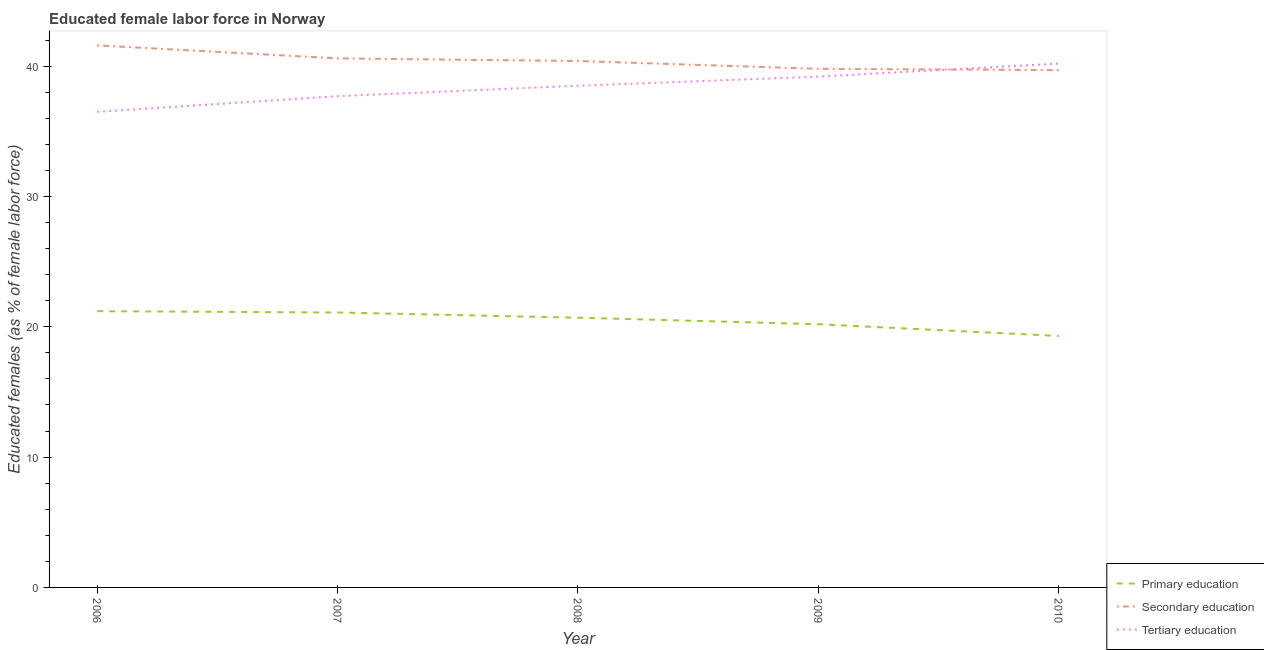How many different coloured lines are there?
Offer a very short reply. 3. Is the number of lines equal to the number of legend labels?
Provide a succinct answer. Yes. What is the percentage of female labor force who received primary education in 2007?
Offer a terse response. 21.1. Across all years, what is the maximum percentage of female labor force who received secondary education?
Give a very brief answer. 41.6. Across all years, what is the minimum percentage of female labor force who received secondary education?
Offer a very short reply. 39.7. In which year was the percentage of female labor force who received secondary education maximum?
Provide a succinct answer. 2006. In which year was the percentage of female labor force who received secondary education minimum?
Provide a succinct answer. 2010. What is the total percentage of female labor force who received tertiary education in the graph?
Your answer should be compact. 192.1. What is the difference between the percentage of female labor force who received primary education in 2007 and that in 2008?
Your response must be concise. 0.4. What is the difference between the percentage of female labor force who received secondary education in 2006 and the percentage of female labor force who received tertiary education in 2009?
Your answer should be very brief. 2.4. What is the average percentage of female labor force who received secondary education per year?
Provide a succinct answer. 40.42. In the year 2007, what is the difference between the percentage of female labor force who received primary education and percentage of female labor force who received secondary education?
Keep it short and to the point. -19.5. What is the ratio of the percentage of female labor force who received tertiary education in 2007 to that in 2008?
Make the answer very short. 0.98. Is the percentage of female labor force who received primary education in 2008 less than that in 2009?
Provide a short and direct response. No. Is the difference between the percentage of female labor force who received secondary education in 2006 and 2008 greater than the difference between the percentage of female labor force who received primary education in 2006 and 2008?
Your response must be concise. Yes. What is the difference between the highest and the second highest percentage of female labor force who received primary education?
Give a very brief answer. 0.1. What is the difference between the highest and the lowest percentage of female labor force who received primary education?
Offer a very short reply. 1.9. In how many years, is the percentage of female labor force who received primary education greater than the average percentage of female labor force who received primary education taken over all years?
Your response must be concise. 3. Is the sum of the percentage of female labor force who received secondary education in 2006 and 2007 greater than the maximum percentage of female labor force who received primary education across all years?
Your response must be concise. Yes. Is it the case that in every year, the sum of the percentage of female labor force who received primary education and percentage of female labor force who received secondary education is greater than the percentage of female labor force who received tertiary education?
Provide a succinct answer. Yes. Is the percentage of female labor force who received secondary education strictly less than the percentage of female labor force who received tertiary education over the years?
Give a very brief answer. No. How many lines are there?
Give a very brief answer. 3. How many years are there in the graph?
Give a very brief answer. 5. Are the values on the major ticks of Y-axis written in scientific E-notation?
Ensure brevity in your answer.  No. Where does the legend appear in the graph?
Your response must be concise. Bottom right. How many legend labels are there?
Provide a short and direct response. 3. What is the title of the graph?
Your answer should be very brief. Educated female labor force in Norway. Does "Infant(male)" appear as one of the legend labels in the graph?
Provide a short and direct response. No. What is the label or title of the X-axis?
Provide a succinct answer. Year. What is the label or title of the Y-axis?
Ensure brevity in your answer.  Educated females (as % of female labor force). What is the Educated females (as % of female labor force) in Primary education in 2006?
Keep it short and to the point. 21.2. What is the Educated females (as % of female labor force) of Secondary education in 2006?
Offer a terse response. 41.6. What is the Educated females (as % of female labor force) in Tertiary education in 2006?
Your answer should be very brief. 36.5. What is the Educated females (as % of female labor force) of Primary education in 2007?
Make the answer very short. 21.1. What is the Educated females (as % of female labor force) in Secondary education in 2007?
Your response must be concise. 40.6. What is the Educated females (as % of female labor force) of Tertiary education in 2007?
Ensure brevity in your answer.  37.7. What is the Educated females (as % of female labor force) of Primary education in 2008?
Provide a succinct answer. 20.7. What is the Educated females (as % of female labor force) of Secondary education in 2008?
Keep it short and to the point. 40.4. What is the Educated females (as % of female labor force) in Tertiary education in 2008?
Offer a terse response. 38.5. What is the Educated females (as % of female labor force) in Primary education in 2009?
Give a very brief answer. 20.2. What is the Educated females (as % of female labor force) in Secondary education in 2009?
Offer a very short reply. 39.8. What is the Educated females (as % of female labor force) in Tertiary education in 2009?
Offer a very short reply. 39.2. What is the Educated females (as % of female labor force) in Primary education in 2010?
Provide a succinct answer. 19.3. What is the Educated females (as % of female labor force) in Secondary education in 2010?
Your response must be concise. 39.7. What is the Educated females (as % of female labor force) of Tertiary education in 2010?
Your response must be concise. 40.2. Across all years, what is the maximum Educated females (as % of female labor force) of Primary education?
Offer a very short reply. 21.2. Across all years, what is the maximum Educated females (as % of female labor force) of Secondary education?
Offer a very short reply. 41.6. Across all years, what is the maximum Educated females (as % of female labor force) of Tertiary education?
Your response must be concise. 40.2. Across all years, what is the minimum Educated females (as % of female labor force) in Primary education?
Make the answer very short. 19.3. Across all years, what is the minimum Educated females (as % of female labor force) in Secondary education?
Make the answer very short. 39.7. Across all years, what is the minimum Educated females (as % of female labor force) of Tertiary education?
Offer a very short reply. 36.5. What is the total Educated females (as % of female labor force) in Primary education in the graph?
Make the answer very short. 102.5. What is the total Educated females (as % of female labor force) in Secondary education in the graph?
Provide a succinct answer. 202.1. What is the total Educated females (as % of female labor force) of Tertiary education in the graph?
Offer a very short reply. 192.1. What is the difference between the Educated females (as % of female labor force) of Primary education in 2006 and that in 2007?
Provide a short and direct response. 0.1. What is the difference between the Educated females (as % of female labor force) of Tertiary education in 2006 and that in 2007?
Offer a terse response. -1.2. What is the difference between the Educated females (as % of female labor force) in Secondary education in 2006 and that in 2008?
Your answer should be very brief. 1.2. What is the difference between the Educated females (as % of female labor force) of Tertiary education in 2006 and that in 2008?
Your answer should be compact. -2. What is the difference between the Educated females (as % of female labor force) in Primary education in 2006 and that in 2009?
Make the answer very short. 1. What is the difference between the Educated females (as % of female labor force) of Primary education in 2006 and that in 2010?
Your answer should be compact. 1.9. What is the difference between the Educated females (as % of female labor force) in Tertiary education in 2006 and that in 2010?
Provide a short and direct response. -3.7. What is the difference between the Educated females (as % of female labor force) of Primary education in 2007 and that in 2008?
Your response must be concise. 0.4. What is the difference between the Educated females (as % of female labor force) of Tertiary education in 2007 and that in 2008?
Keep it short and to the point. -0.8. What is the difference between the Educated females (as % of female labor force) in Tertiary education in 2007 and that in 2010?
Your response must be concise. -2.5. What is the difference between the Educated females (as % of female labor force) in Tertiary education in 2008 and that in 2009?
Ensure brevity in your answer.  -0.7. What is the difference between the Educated females (as % of female labor force) of Secondary education in 2008 and that in 2010?
Offer a terse response. 0.7. What is the difference between the Educated females (as % of female labor force) in Tertiary education in 2009 and that in 2010?
Your answer should be very brief. -1. What is the difference between the Educated females (as % of female labor force) of Primary education in 2006 and the Educated females (as % of female labor force) of Secondary education in 2007?
Make the answer very short. -19.4. What is the difference between the Educated females (as % of female labor force) in Primary education in 2006 and the Educated females (as % of female labor force) in Tertiary education in 2007?
Offer a very short reply. -16.5. What is the difference between the Educated females (as % of female labor force) in Primary education in 2006 and the Educated females (as % of female labor force) in Secondary education in 2008?
Ensure brevity in your answer.  -19.2. What is the difference between the Educated females (as % of female labor force) of Primary education in 2006 and the Educated females (as % of female labor force) of Tertiary education in 2008?
Offer a very short reply. -17.3. What is the difference between the Educated females (as % of female labor force) of Secondary education in 2006 and the Educated females (as % of female labor force) of Tertiary education in 2008?
Provide a succinct answer. 3.1. What is the difference between the Educated females (as % of female labor force) in Primary education in 2006 and the Educated females (as % of female labor force) in Secondary education in 2009?
Offer a terse response. -18.6. What is the difference between the Educated females (as % of female labor force) of Primary education in 2006 and the Educated females (as % of female labor force) of Tertiary education in 2009?
Keep it short and to the point. -18. What is the difference between the Educated females (as % of female labor force) in Secondary education in 2006 and the Educated females (as % of female labor force) in Tertiary education in 2009?
Offer a terse response. 2.4. What is the difference between the Educated females (as % of female labor force) of Primary education in 2006 and the Educated females (as % of female labor force) of Secondary education in 2010?
Your answer should be compact. -18.5. What is the difference between the Educated females (as % of female labor force) in Secondary education in 2006 and the Educated females (as % of female labor force) in Tertiary education in 2010?
Your answer should be very brief. 1.4. What is the difference between the Educated females (as % of female labor force) of Primary education in 2007 and the Educated females (as % of female labor force) of Secondary education in 2008?
Provide a short and direct response. -19.3. What is the difference between the Educated females (as % of female labor force) of Primary education in 2007 and the Educated females (as % of female labor force) of Tertiary education in 2008?
Keep it short and to the point. -17.4. What is the difference between the Educated females (as % of female labor force) of Primary education in 2007 and the Educated females (as % of female labor force) of Secondary education in 2009?
Keep it short and to the point. -18.7. What is the difference between the Educated females (as % of female labor force) of Primary education in 2007 and the Educated females (as % of female labor force) of Tertiary education in 2009?
Your response must be concise. -18.1. What is the difference between the Educated females (as % of female labor force) in Primary education in 2007 and the Educated females (as % of female labor force) in Secondary education in 2010?
Your answer should be compact. -18.6. What is the difference between the Educated females (as % of female labor force) of Primary education in 2007 and the Educated females (as % of female labor force) of Tertiary education in 2010?
Offer a very short reply. -19.1. What is the difference between the Educated females (as % of female labor force) of Secondary education in 2007 and the Educated females (as % of female labor force) of Tertiary education in 2010?
Your answer should be very brief. 0.4. What is the difference between the Educated females (as % of female labor force) in Primary education in 2008 and the Educated females (as % of female labor force) in Secondary education in 2009?
Offer a terse response. -19.1. What is the difference between the Educated females (as % of female labor force) of Primary education in 2008 and the Educated females (as % of female labor force) of Tertiary education in 2009?
Offer a very short reply. -18.5. What is the difference between the Educated females (as % of female labor force) in Secondary education in 2008 and the Educated females (as % of female labor force) in Tertiary education in 2009?
Keep it short and to the point. 1.2. What is the difference between the Educated females (as % of female labor force) of Primary education in 2008 and the Educated females (as % of female labor force) of Tertiary education in 2010?
Keep it short and to the point. -19.5. What is the difference between the Educated females (as % of female labor force) of Secondary education in 2008 and the Educated females (as % of female labor force) of Tertiary education in 2010?
Make the answer very short. 0.2. What is the difference between the Educated females (as % of female labor force) of Primary education in 2009 and the Educated females (as % of female labor force) of Secondary education in 2010?
Provide a short and direct response. -19.5. What is the average Educated females (as % of female labor force) of Secondary education per year?
Ensure brevity in your answer.  40.42. What is the average Educated females (as % of female labor force) of Tertiary education per year?
Keep it short and to the point. 38.42. In the year 2006, what is the difference between the Educated females (as % of female labor force) of Primary education and Educated females (as % of female labor force) of Secondary education?
Provide a short and direct response. -20.4. In the year 2006, what is the difference between the Educated females (as % of female labor force) in Primary education and Educated females (as % of female labor force) in Tertiary education?
Provide a succinct answer. -15.3. In the year 2006, what is the difference between the Educated females (as % of female labor force) in Secondary education and Educated females (as % of female labor force) in Tertiary education?
Ensure brevity in your answer.  5.1. In the year 2007, what is the difference between the Educated females (as % of female labor force) of Primary education and Educated females (as % of female labor force) of Secondary education?
Your answer should be very brief. -19.5. In the year 2007, what is the difference between the Educated females (as % of female labor force) in Primary education and Educated females (as % of female labor force) in Tertiary education?
Ensure brevity in your answer.  -16.6. In the year 2008, what is the difference between the Educated females (as % of female labor force) of Primary education and Educated females (as % of female labor force) of Secondary education?
Your answer should be very brief. -19.7. In the year 2008, what is the difference between the Educated females (as % of female labor force) of Primary education and Educated females (as % of female labor force) of Tertiary education?
Ensure brevity in your answer.  -17.8. In the year 2008, what is the difference between the Educated females (as % of female labor force) of Secondary education and Educated females (as % of female labor force) of Tertiary education?
Give a very brief answer. 1.9. In the year 2009, what is the difference between the Educated females (as % of female labor force) of Primary education and Educated females (as % of female labor force) of Secondary education?
Offer a very short reply. -19.6. In the year 2009, what is the difference between the Educated females (as % of female labor force) of Primary education and Educated females (as % of female labor force) of Tertiary education?
Your response must be concise. -19. In the year 2009, what is the difference between the Educated females (as % of female labor force) in Secondary education and Educated females (as % of female labor force) in Tertiary education?
Give a very brief answer. 0.6. In the year 2010, what is the difference between the Educated females (as % of female labor force) in Primary education and Educated females (as % of female labor force) in Secondary education?
Make the answer very short. -20.4. In the year 2010, what is the difference between the Educated females (as % of female labor force) in Primary education and Educated females (as % of female labor force) in Tertiary education?
Your answer should be very brief. -20.9. In the year 2010, what is the difference between the Educated females (as % of female labor force) in Secondary education and Educated females (as % of female labor force) in Tertiary education?
Give a very brief answer. -0.5. What is the ratio of the Educated females (as % of female labor force) in Secondary education in 2006 to that in 2007?
Provide a succinct answer. 1.02. What is the ratio of the Educated females (as % of female labor force) in Tertiary education in 2006 to that in 2007?
Keep it short and to the point. 0.97. What is the ratio of the Educated females (as % of female labor force) of Primary education in 2006 to that in 2008?
Your answer should be very brief. 1.02. What is the ratio of the Educated females (as % of female labor force) of Secondary education in 2006 to that in 2008?
Offer a terse response. 1.03. What is the ratio of the Educated females (as % of female labor force) of Tertiary education in 2006 to that in 2008?
Offer a terse response. 0.95. What is the ratio of the Educated females (as % of female labor force) of Primary education in 2006 to that in 2009?
Offer a very short reply. 1.05. What is the ratio of the Educated females (as % of female labor force) in Secondary education in 2006 to that in 2009?
Make the answer very short. 1.05. What is the ratio of the Educated females (as % of female labor force) in Tertiary education in 2006 to that in 2009?
Ensure brevity in your answer.  0.93. What is the ratio of the Educated females (as % of female labor force) of Primary education in 2006 to that in 2010?
Offer a very short reply. 1.1. What is the ratio of the Educated females (as % of female labor force) of Secondary education in 2006 to that in 2010?
Make the answer very short. 1.05. What is the ratio of the Educated females (as % of female labor force) of Tertiary education in 2006 to that in 2010?
Give a very brief answer. 0.91. What is the ratio of the Educated females (as % of female labor force) in Primary education in 2007 to that in 2008?
Provide a succinct answer. 1.02. What is the ratio of the Educated females (as % of female labor force) in Tertiary education in 2007 to that in 2008?
Ensure brevity in your answer.  0.98. What is the ratio of the Educated females (as % of female labor force) in Primary education in 2007 to that in 2009?
Your answer should be very brief. 1.04. What is the ratio of the Educated females (as % of female labor force) in Secondary education in 2007 to that in 2009?
Provide a succinct answer. 1.02. What is the ratio of the Educated females (as % of female labor force) in Tertiary education in 2007 to that in 2009?
Offer a very short reply. 0.96. What is the ratio of the Educated females (as % of female labor force) of Primary education in 2007 to that in 2010?
Your answer should be very brief. 1.09. What is the ratio of the Educated females (as % of female labor force) in Secondary education in 2007 to that in 2010?
Your response must be concise. 1.02. What is the ratio of the Educated females (as % of female labor force) of Tertiary education in 2007 to that in 2010?
Ensure brevity in your answer.  0.94. What is the ratio of the Educated females (as % of female labor force) in Primary education in 2008 to that in 2009?
Ensure brevity in your answer.  1.02. What is the ratio of the Educated females (as % of female labor force) in Secondary education in 2008 to that in 2009?
Your response must be concise. 1.02. What is the ratio of the Educated females (as % of female labor force) in Tertiary education in 2008 to that in 2009?
Offer a very short reply. 0.98. What is the ratio of the Educated females (as % of female labor force) in Primary education in 2008 to that in 2010?
Provide a short and direct response. 1.07. What is the ratio of the Educated females (as % of female labor force) in Secondary education in 2008 to that in 2010?
Make the answer very short. 1.02. What is the ratio of the Educated females (as % of female labor force) of Tertiary education in 2008 to that in 2010?
Your answer should be very brief. 0.96. What is the ratio of the Educated females (as % of female labor force) of Primary education in 2009 to that in 2010?
Your answer should be very brief. 1.05. What is the ratio of the Educated females (as % of female labor force) in Tertiary education in 2009 to that in 2010?
Your answer should be compact. 0.98. What is the difference between the highest and the second highest Educated females (as % of female labor force) of Primary education?
Provide a short and direct response. 0.1. What is the difference between the highest and the second highest Educated females (as % of female labor force) in Secondary education?
Your response must be concise. 1. What is the difference between the highest and the lowest Educated females (as % of female labor force) in Secondary education?
Give a very brief answer. 1.9. What is the difference between the highest and the lowest Educated females (as % of female labor force) of Tertiary education?
Your answer should be compact. 3.7. 